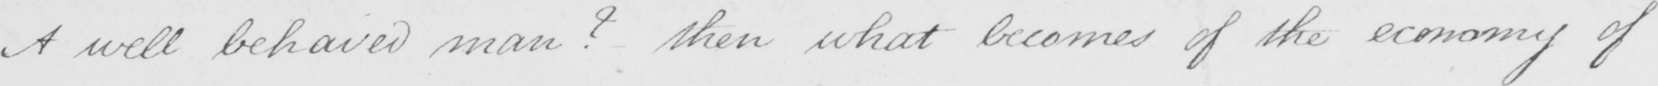Can you tell me what this handwritten text says? A well behaved man ?  then what becomes of the economy of 